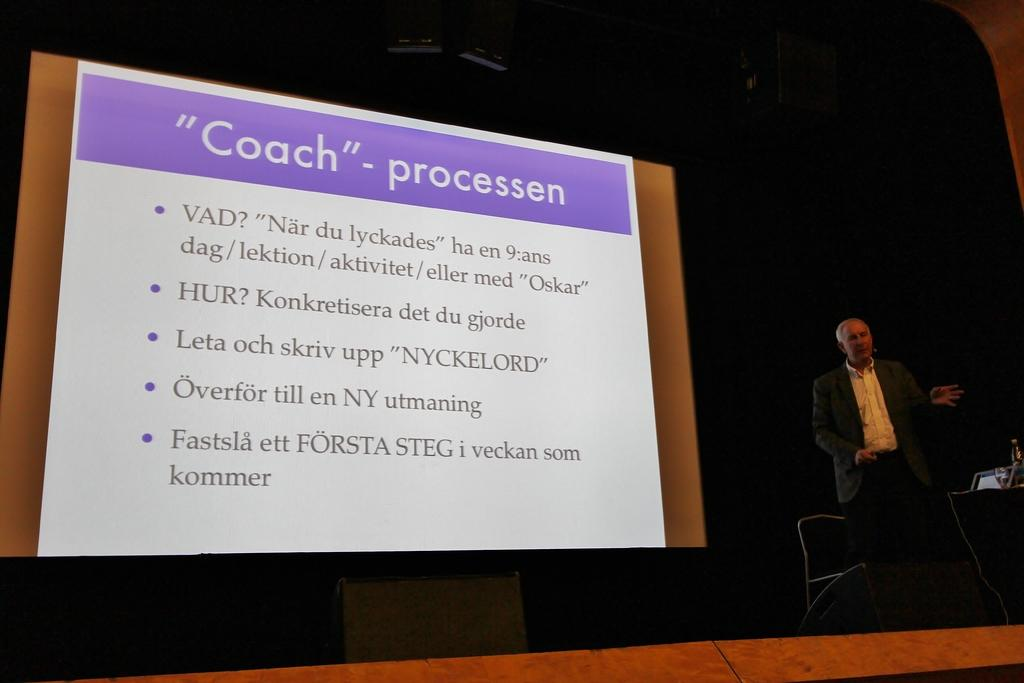What is the main subject of the image? The main subject of the image is a man. What is the man doing in the image? The man is standing in the image. What other objects are present in the image? There is a chair and a projector screen in the image. Is the man sleeping in the image? No, the man is not sleeping in the image; he is standing. What type of chain is connected to the projector screen in the image? There is no chain present in the image, as it only features a man standing, a chair, and a projector screen. 